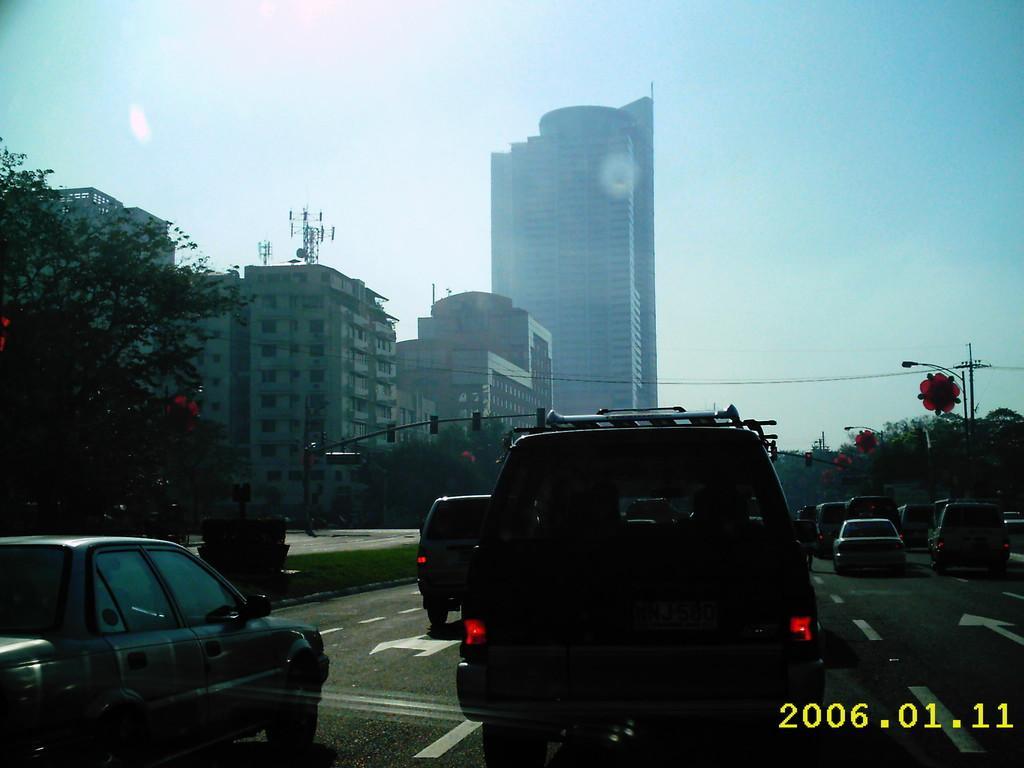Please provide a concise description of this image. In this image there are trees and buildings on the left corner. There is a road at the bottom. There are vehicles in the foreground. There are vehicles, poles, and trees on the right corner. There is sky at the top. And there are buildings in the background. 